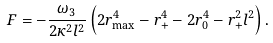Convert formula to latex. <formula><loc_0><loc_0><loc_500><loc_500>F = - \frac { \omega _ { 3 } } { 2 \kappa ^ { 2 } l ^ { 2 } } \left ( 2 r ^ { 4 } _ { \max } - r _ { + } ^ { 4 } - 2 r _ { 0 } ^ { 4 } - r _ { + } ^ { 2 } l ^ { 2 } \right ) .</formula> 